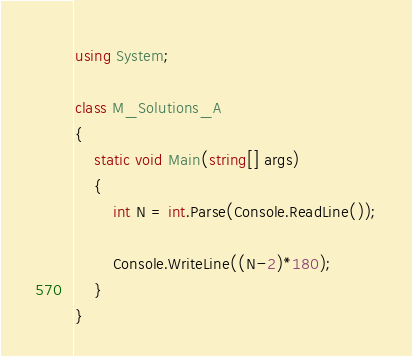Convert code to text. <code><loc_0><loc_0><loc_500><loc_500><_C#_>using System;

class M_Solutions_A
{
    static void Main(string[] args)
    {
        int N = int.Parse(Console.ReadLine());

        Console.WriteLine((N-2)*180);
    }
}</code> 